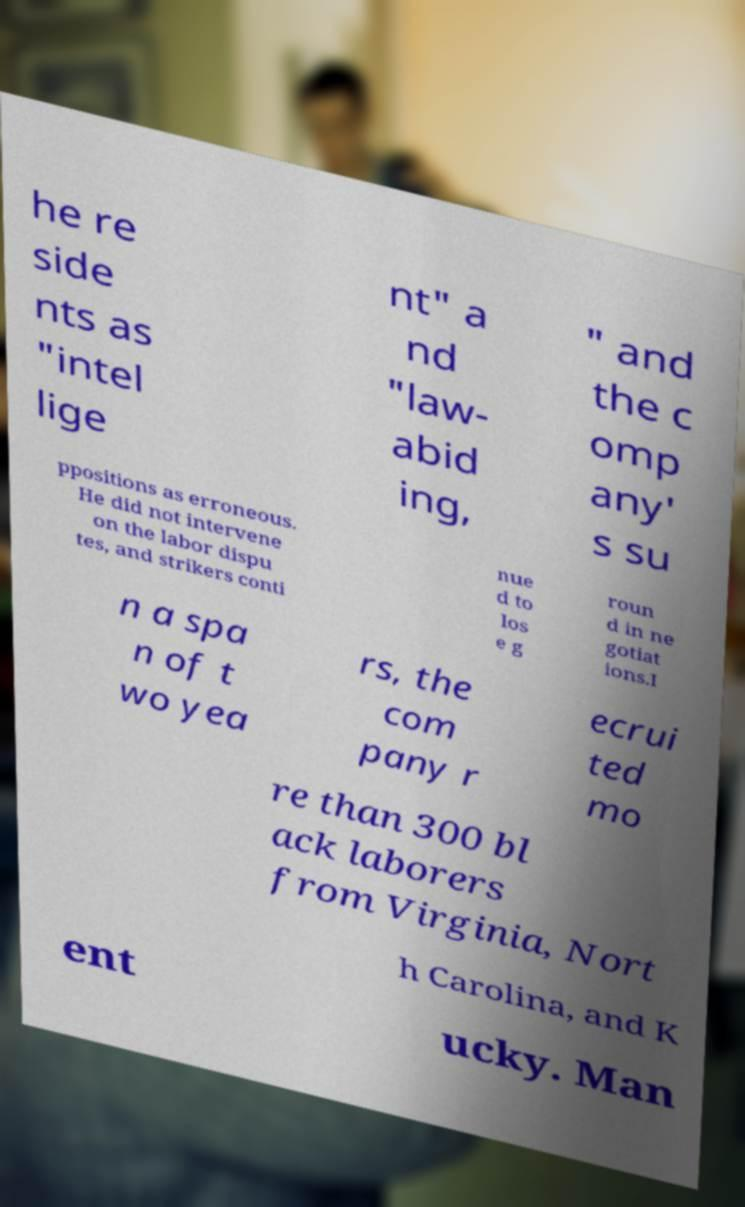Please identify and transcribe the text found in this image. he re side nts as "intel lige nt" a nd "law- abid ing, " and the c omp any' s su ppositions as erroneous. He did not intervene on the labor dispu tes, and strikers conti nue d to los e g roun d in ne gotiat ions.I n a spa n of t wo yea rs, the com pany r ecrui ted mo re than 300 bl ack laborers from Virginia, Nort h Carolina, and K ent ucky. Man 